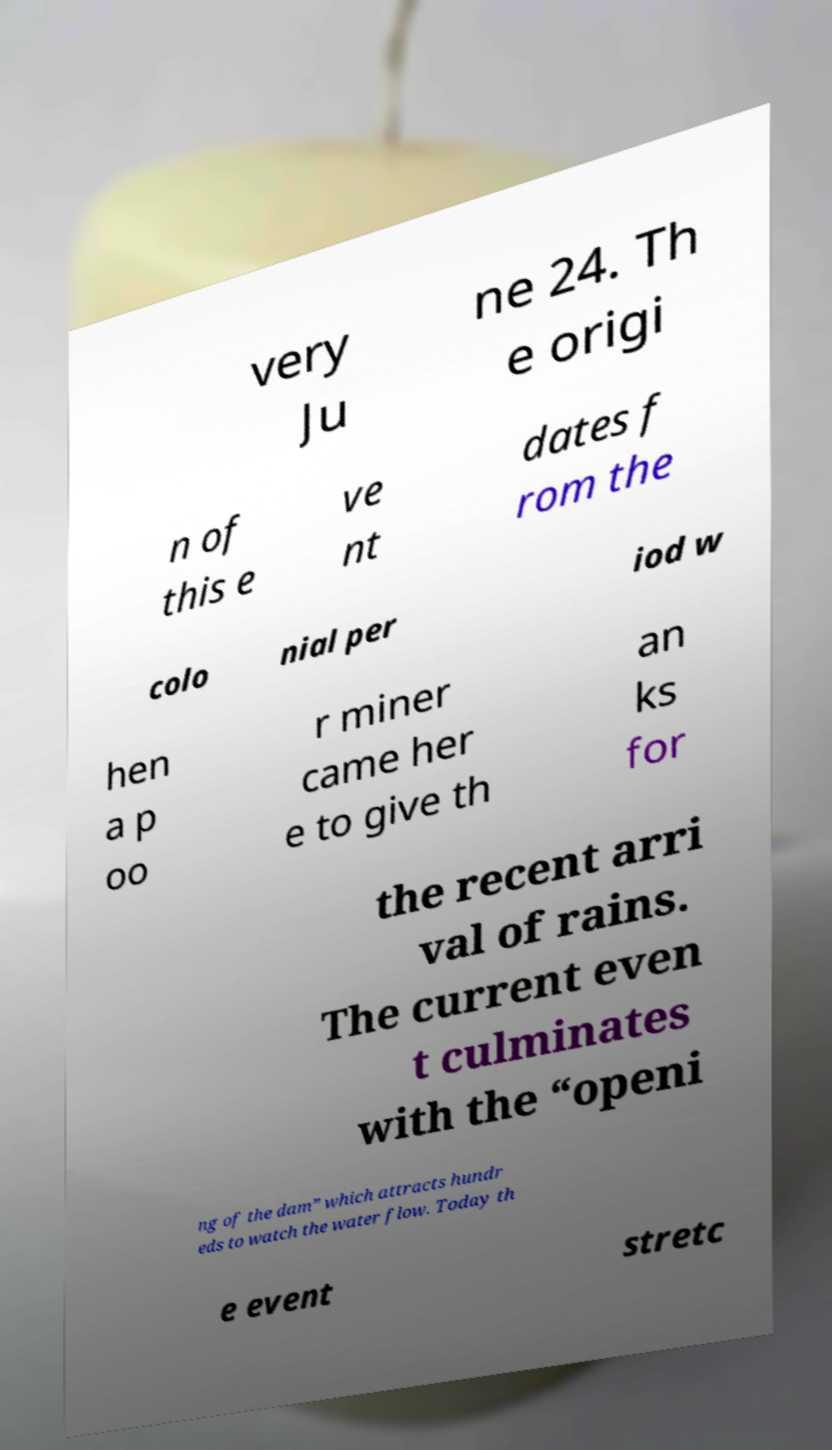What messages or text are displayed in this image? I need them in a readable, typed format. very Ju ne 24. Th e origi n of this e ve nt dates f rom the colo nial per iod w hen a p oo r miner came her e to give th an ks for the recent arri val of rains. The current even t culminates with the “openi ng of the dam” which attracts hundr eds to watch the water flow. Today th e event stretc 